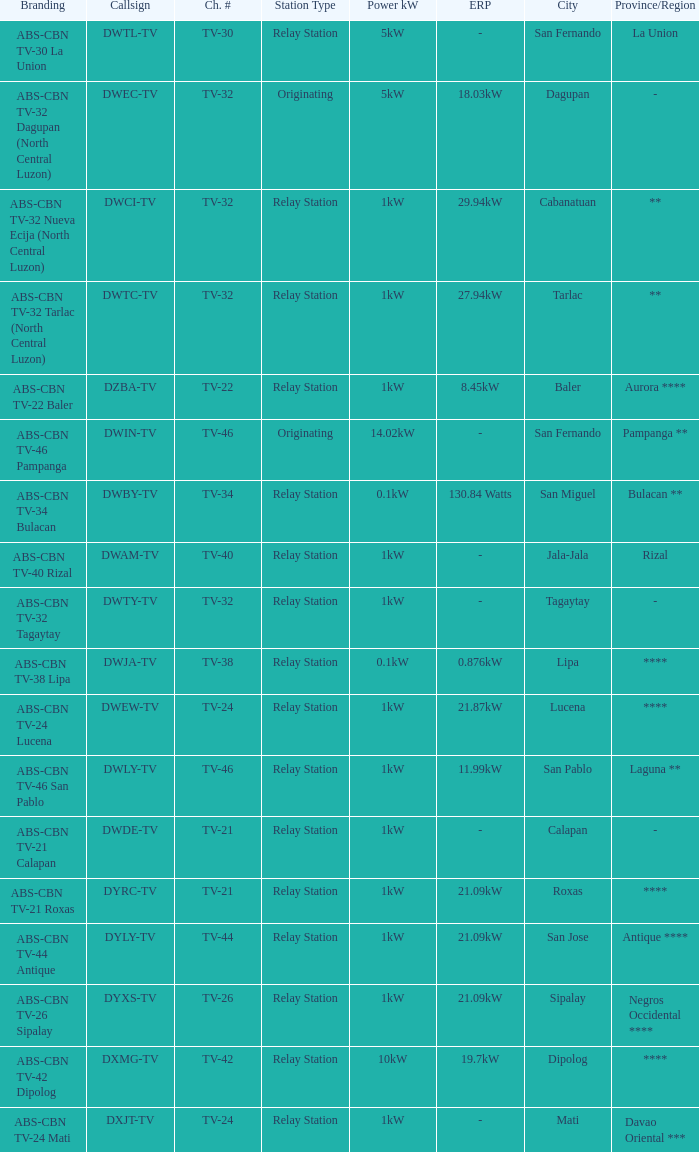How many brandings are there where the Power kW (ERP) is 1kW (29.94kW ERP)? 1.0. Could you parse the entire table as a dict? {'header': ['Branding', 'Callsign', 'Ch. #', 'Station Type', 'Power kW', 'ERP', 'City', 'Province/Region'], 'rows': [['ABS-CBN TV-30 La Union', 'DWTL-TV', 'TV-30', 'Relay Station', '5kW', '-', 'San Fernando', 'La Union'], ['ABS-CBN TV-32 Dagupan (North Central Luzon)', 'DWEC-TV', 'TV-32', 'Originating', '5kW', '18.03kW', 'Dagupan', '-'], ['ABS-CBN TV-32 Nueva Ecija (North Central Luzon)', 'DWCI-TV', 'TV-32', 'Relay Station', '1kW', '29.94kW', 'Cabanatuan', '**'], ['ABS-CBN TV-32 Tarlac (North Central Luzon)', 'DWTC-TV', 'TV-32', 'Relay Station', '1kW', '27.94kW', 'Tarlac', '**'], ['ABS-CBN TV-22 Baler', 'DZBA-TV', 'TV-22', 'Relay Station', '1kW', '8.45kW', 'Baler', 'Aurora ****'], ['ABS-CBN TV-46 Pampanga', 'DWIN-TV', 'TV-46', 'Originating', '14.02kW', '-', 'San Fernando', 'Pampanga **'], ['ABS-CBN TV-34 Bulacan', 'DWBY-TV', 'TV-34', 'Relay Station', '0.1kW', '130.84 Watts', 'San Miguel', 'Bulacan **'], ['ABS-CBN TV-40 Rizal', 'DWAM-TV', 'TV-40', 'Relay Station', '1kW', '-', 'Jala-Jala', 'Rizal'], ['ABS-CBN TV-32 Tagaytay', 'DWTY-TV', 'TV-32', 'Relay Station', '1kW', '-', 'Tagaytay', '-'], ['ABS-CBN TV-38 Lipa', 'DWJA-TV', 'TV-38', 'Relay Station', '0.1kW', '0.876kW', 'Lipa', '****'], ['ABS-CBN TV-24 Lucena', 'DWEW-TV', 'TV-24', 'Relay Station', '1kW', '21.87kW', 'Lucena', '****'], ['ABS-CBN TV-46 San Pablo', 'DWLY-TV', 'TV-46', 'Relay Station', '1kW', '11.99kW', 'San Pablo', 'Laguna **'], ['ABS-CBN TV-21 Calapan', 'DWDE-TV', 'TV-21', 'Relay Station', '1kW', '-', 'Calapan', '-'], ['ABS-CBN TV-21 Roxas', 'DYRC-TV', 'TV-21', 'Relay Station', '1kW', '21.09kW', 'Roxas', '****'], ['ABS-CBN TV-44 Antique', 'DYLY-TV', 'TV-44', 'Relay Station', '1kW', '21.09kW', 'San Jose', 'Antique ****'], ['ABS-CBN TV-26 Sipalay', 'DYXS-TV', 'TV-26', 'Relay Station', '1kW', '21.09kW', 'Sipalay', 'Negros Occidental ****'], ['ABS-CBN TV-42 Dipolog', 'DXMG-TV', 'TV-42', 'Relay Station', '10kW', '19.7kW', 'Dipolog', '****'], ['ABS-CBN TV-24 Mati', 'DXJT-TV', 'TV-24', 'Relay Station', '1kW', '-', 'Mati', 'Davao Oriental ***']]} 